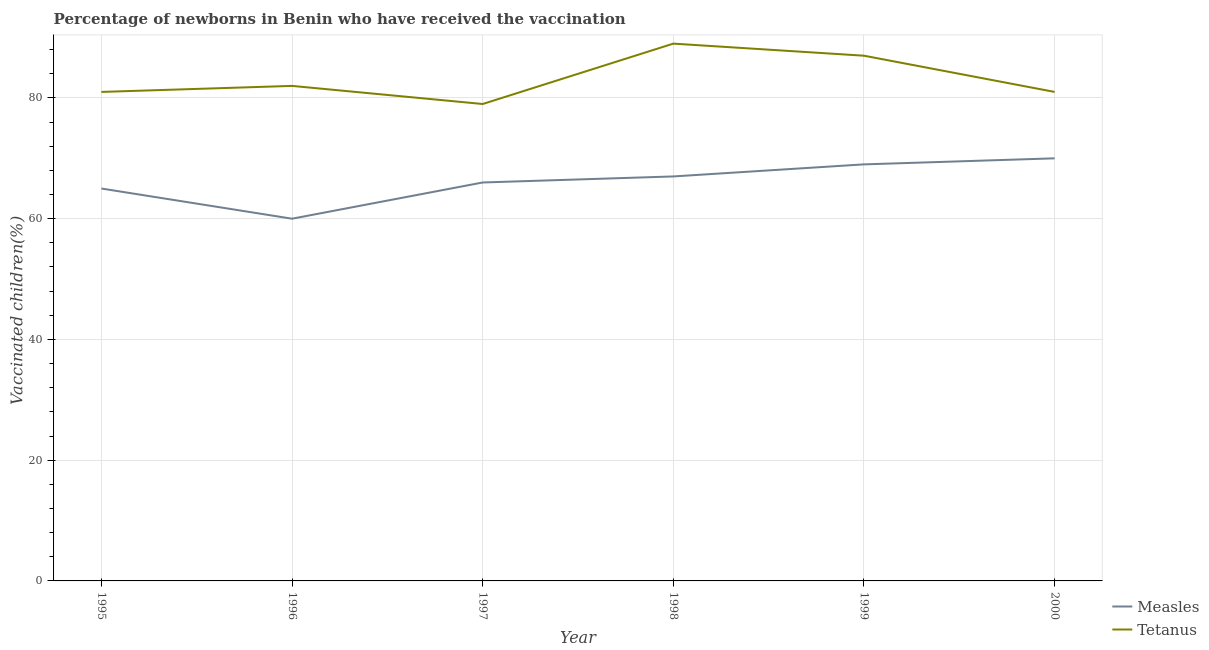Does the line corresponding to percentage of newborns who received vaccination for tetanus intersect with the line corresponding to percentage of newborns who received vaccination for measles?
Provide a succinct answer. No. Is the number of lines equal to the number of legend labels?
Your response must be concise. Yes. What is the percentage of newborns who received vaccination for tetanus in 1997?
Provide a succinct answer. 79. Across all years, what is the maximum percentage of newborns who received vaccination for tetanus?
Keep it short and to the point. 89. Across all years, what is the minimum percentage of newborns who received vaccination for tetanus?
Make the answer very short. 79. In which year was the percentage of newborns who received vaccination for measles maximum?
Your answer should be compact. 2000. In which year was the percentage of newborns who received vaccination for tetanus minimum?
Provide a short and direct response. 1997. What is the total percentage of newborns who received vaccination for tetanus in the graph?
Your answer should be very brief. 499. What is the difference between the percentage of newborns who received vaccination for measles in 1996 and that in 1997?
Provide a succinct answer. -6. What is the difference between the percentage of newborns who received vaccination for tetanus in 1999 and the percentage of newborns who received vaccination for measles in 2000?
Provide a short and direct response. 17. What is the average percentage of newborns who received vaccination for tetanus per year?
Provide a succinct answer. 83.17. In the year 1997, what is the difference between the percentage of newborns who received vaccination for tetanus and percentage of newborns who received vaccination for measles?
Make the answer very short. 13. What is the ratio of the percentage of newborns who received vaccination for tetanus in 1995 to that in 1996?
Your answer should be very brief. 0.99. What is the difference between the highest and the second highest percentage of newborns who received vaccination for measles?
Your answer should be very brief. 1. What is the difference between the highest and the lowest percentage of newborns who received vaccination for tetanus?
Your response must be concise. 10. In how many years, is the percentage of newborns who received vaccination for tetanus greater than the average percentage of newborns who received vaccination for tetanus taken over all years?
Ensure brevity in your answer.  2. How many lines are there?
Keep it short and to the point. 2. Are the values on the major ticks of Y-axis written in scientific E-notation?
Ensure brevity in your answer.  No. Does the graph contain grids?
Offer a very short reply. Yes. Where does the legend appear in the graph?
Keep it short and to the point. Bottom right. How are the legend labels stacked?
Your answer should be very brief. Vertical. What is the title of the graph?
Your answer should be compact. Percentage of newborns in Benin who have received the vaccination. Does "Goods" appear as one of the legend labels in the graph?
Ensure brevity in your answer.  No. What is the label or title of the X-axis?
Your answer should be very brief. Year. What is the label or title of the Y-axis?
Provide a succinct answer. Vaccinated children(%)
. What is the Vaccinated children(%)
 of Measles in 1995?
Provide a short and direct response. 65. What is the Vaccinated children(%)
 in Tetanus in 1995?
Your answer should be very brief. 81. What is the Vaccinated children(%)
 in Tetanus in 1996?
Make the answer very short. 82. What is the Vaccinated children(%)
 in Tetanus in 1997?
Make the answer very short. 79. What is the Vaccinated children(%)
 in Tetanus in 1998?
Offer a very short reply. 89. What is the Vaccinated children(%)
 in Measles in 2000?
Give a very brief answer. 70. What is the Vaccinated children(%)
 in Tetanus in 2000?
Keep it short and to the point. 81. Across all years, what is the maximum Vaccinated children(%)
 of Tetanus?
Offer a very short reply. 89. Across all years, what is the minimum Vaccinated children(%)
 in Measles?
Your response must be concise. 60. Across all years, what is the minimum Vaccinated children(%)
 of Tetanus?
Your answer should be very brief. 79. What is the total Vaccinated children(%)
 of Measles in the graph?
Offer a terse response. 397. What is the total Vaccinated children(%)
 in Tetanus in the graph?
Your answer should be very brief. 499. What is the difference between the Vaccinated children(%)
 of Measles in 1995 and that in 1996?
Your answer should be very brief. 5. What is the difference between the Vaccinated children(%)
 in Tetanus in 1995 and that in 1996?
Offer a very short reply. -1. What is the difference between the Vaccinated children(%)
 in Tetanus in 1995 and that in 1997?
Your answer should be very brief. 2. What is the difference between the Vaccinated children(%)
 in Measles in 1995 and that in 1998?
Make the answer very short. -2. What is the difference between the Vaccinated children(%)
 in Tetanus in 1995 and that in 1998?
Offer a terse response. -8. What is the difference between the Vaccinated children(%)
 in Tetanus in 1995 and that in 1999?
Offer a very short reply. -6. What is the difference between the Vaccinated children(%)
 of Measles in 1996 and that in 1998?
Provide a short and direct response. -7. What is the difference between the Vaccinated children(%)
 in Tetanus in 1996 and that in 1998?
Ensure brevity in your answer.  -7. What is the difference between the Vaccinated children(%)
 of Measles in 1996 and that in 1999?
Offer a terse response. -9. What is the difference between the Vaccinated children(%)
 in Tetanus in 1996 and that in 1999?
Provide a succinct answer. -5. What is the difference between the Vaccinated children(%)
 in Measles in 1996 and that in 2000?
Keep it short and to the point. -10. What is the difference between the Vaccinated children(%)
 in Measles in 1997 and that in 1998?
Keep it short and to the point. -1. What is the difference between the Vaccinated children(%)
 in Measles in 1999 and that in 2000?
Provide a succinct answer. -1. What is the difference between the Vaccinated children(%)
 in Tetanus in 1999 and that in 2000?
Make the answer very short. 6. What is the difference between the Vaccinated children(%)
 in Measles in 1995 and the Vaccinated children(%)
 in Tetanus in 1998?
Make the answer very short. -24. What is the difference between the Vaccinated children(%)
 in Measles in 1995 and the Vaccinated children(%)
 in Tetanus in 1999?
Offer a very short reply. -22. What is the difference between the Vaccinated children(%)
 in Measles in 1995 and the Vaccinated children(%)
 in Tetanus in 2000?
Your answer should be very brief. -16. What is the difference between the Vaccinated children(%)
 in Measles in 1996 and the Vaccinated children(%)
 in Tetanus in 1999?
Make the answer very short. -27. What is the difference between the Vaccinated children(%)
 of Measles in 1996 and the Vaccinated children(%)
 of Tetanus in 2000?
Ensure brevity in your answer.  -21. What is the difference between the Vaccinated children(%)
 of Measles in 1997 and the Vaccinated children(%)
 of Tetanus in 1998?
Your answer should be very brief. -23. What is the difference between the Vaccinated children(%)
 in Measles in 1997 and the Vaccinated children(%)
 in Tetanus in 1999?
Give a very brief answer. -21. What is the difference between the Vaccinated children(%)
 of Measles in 1999 and the Vaccinated children(%)
 of Tetanus in 2000?
Provide a succinct answer. -12. What is the average Vaccinated children(%)
 of Measles per year?
Provide a short and direct response. 66.17. What is the average Vaccinated children(%)
 in Tetanus per year?
Give a very brief answer. 83.17. In the year 1997, what is the difference between the Vaccinated children(%)
 of Measles and Vaccinated children(%)
 of Tetanus?
Offer a terse response. -13. In the year 1999, what is the difference between the Vaccinated children(%)
 of Measles and Vaccinated children(%)
 of Tetanus?
Keep it short and to the point. -18. What is the ratio of the Vaccinated children(%)
 in Measles in 1995 to that in 1996?
Your response must be concise. 1.08. What is the ratio of the Vaccinated children(%)
 of Tetanus in 1995 to that in 1996?
Provide a succinct answer. 0.99. What is the ratio of the Vaccinated children(%)
 of Tetanus in 1995 to that in 1997?
Ensure brevity in your answer.  1.03. What is the ratio of the Vaccinated children(%)
 in Measles in 1995 to that in 1998?
Your answer should be compact. 0.97. What is the ratio of the Vaccinated children(%)
 in Tetanus in 1995 to that in 1998?
Your answer should be compact. 0.91. What is the ratio of the Vaccinated children(%)
 of Measles in 1995 to that in 1999?
Make the answer very short. 0.94. What is the ratio of the Vaccinated children(%)
 of Tetanus in 1995 to that in 1999?
Provide a short and direct response. 0.93. What is the ratio of the Vaccinated children(%)
 in Measles in 1995 to that in 2000?
Your response must be concise. 0.93. What is the ratio of the Vaccinated children(%)
 of Tetanus in 1996 to that in 1997?
Offer a very short reply. 1.04. What is the ratio of the Vaccinated children(%)
 of Measles in 1996 to that in 1998?
Keep it short and to the point. 0.9. What is the ratio of the Vaccinated children(%)
 in Tetanus in 1996 to that in 1998?
Provide a succinct answer. 0.92. What is the ratio of the Vaccinated children(%)
 of Measles in 1996 to that in 1999?
Make the answer very short. 0.87. What is the ratio of the Vaccinated children(%)
 in Tetanus in 1996 to that in 1999?
Ensure brevity in your answer.  0.94. What is the ratio of the Vaccinated children(%)
 in Tetanus in 1996 to that in 2000?
Offer a terse response. 1.01. What is the ratio of the Vaccinated children(%)
 in Measles in 1997 to that in 1998?
Your answer should be compact. 0.99. What is the ratio of the Vaccinated children(%)
 of Tetanus in 1997 to that in 1998?
Offer a terse response. 0.89. What is the ratio of the Vaccinated children(%)
 of Measles in 1997 to that in 1999?
Make the answer very short. 0.96. What is the ratio of the Vaccinated children(%)
 in Tetanus in 1997 to that in 1999?
Your response must be concise. 0.91. What is the ratio of the Vaccinated children(%)
 in Measles in 1997 to that in 2000?
Keep it short and to the point. 0.94. What is the ratio of the Vaccinated children(%)
 in Tetanus in 1997 to that in 2000?
Keep it short and to the point. 0.98. What is the ratio of the Vaccinated children(%)
 in Measles in 1998 to that in 1999?
Your answer should be compact. 0.97. What is the ratio of the Vaccinated children(%)
 in Measles in 1998 to that in 2000?
Provide a succinct answer. 0.96. What is the ratio of the Vaccinated children(%)
 of Tetanus in 1998 to that in 2000?
Your response must be concise. 1.1. What is the ratio of the Vaccinated children(%)
 of Measles in 1999 to that in 2000?
Offer a very short reply. 0.99. What is the ratio of the Vaccinated children(%)
 of Tetanus in 1999 to that in 2000?
Offer a very short reply. 1.07. What is the difference between the highest and the second highest Vaccinated children(%)
 of Measles?
Make the answer very short. 1. What is the difference between the highest and the lowest Vaccinated children(%)
 in Measles?
Your response must be concise. 10. 